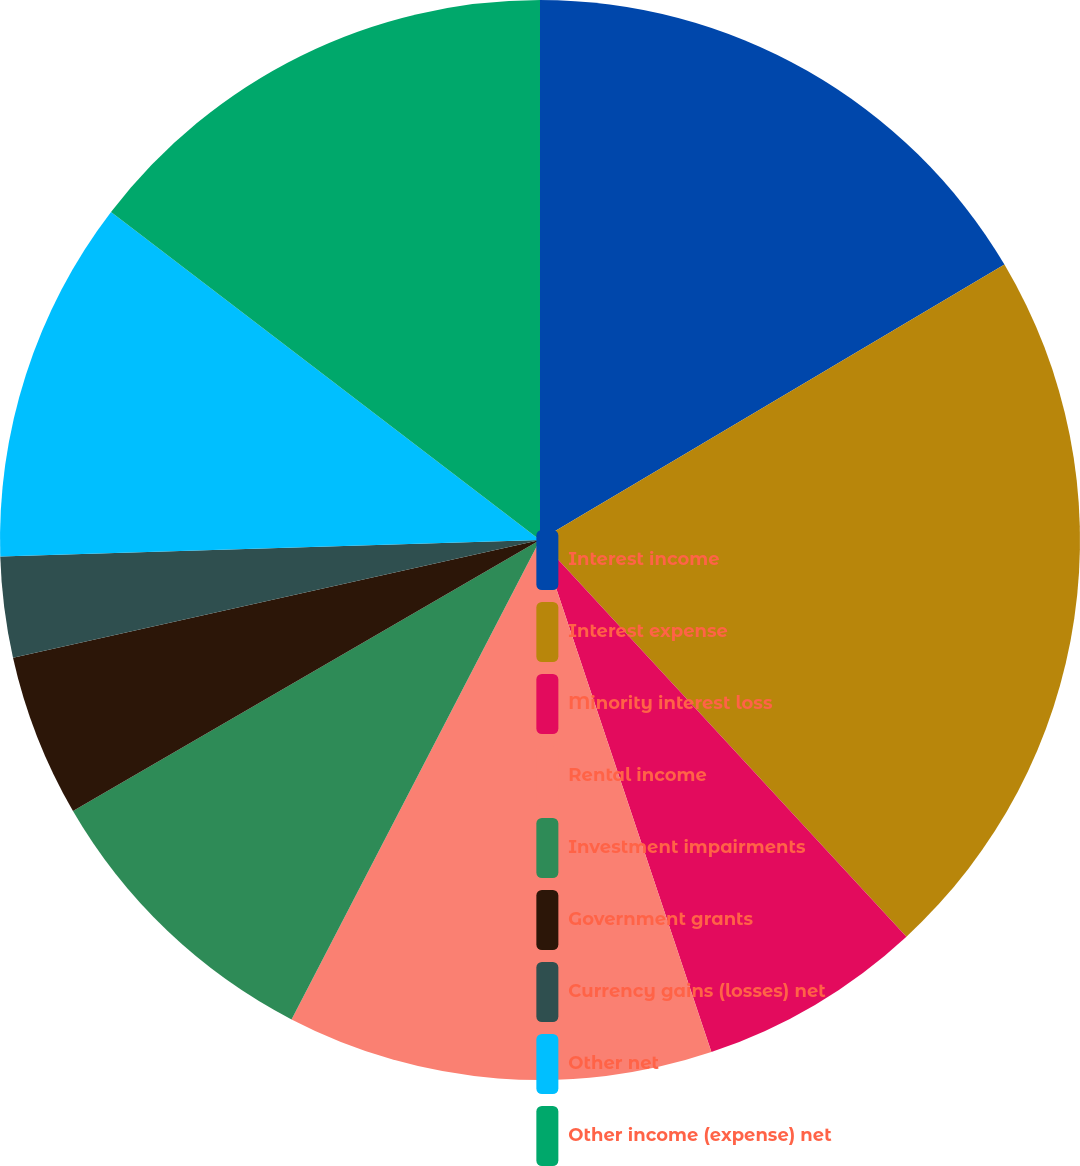<chart> <loc_0><loc_0><loc_500><loc_500><pie_chart><fcel>Interest income<fcel>Interest expense<fcel>Minority interest loss<fcel>Rental income<fcel>Investment impairments<fcel>Government grants<fcel>Currency gains (losses) net<fcel>Other net<fcel>Other income (expense) net<nl><fcel>16.48%<fcel>21.65%<fcel>6.73%<fcel>12.75%<fcel>9.02%<fcel>4.87%<fcel>3.01%<fcel>10.88%<fcel>14.61%<nl></chart> 